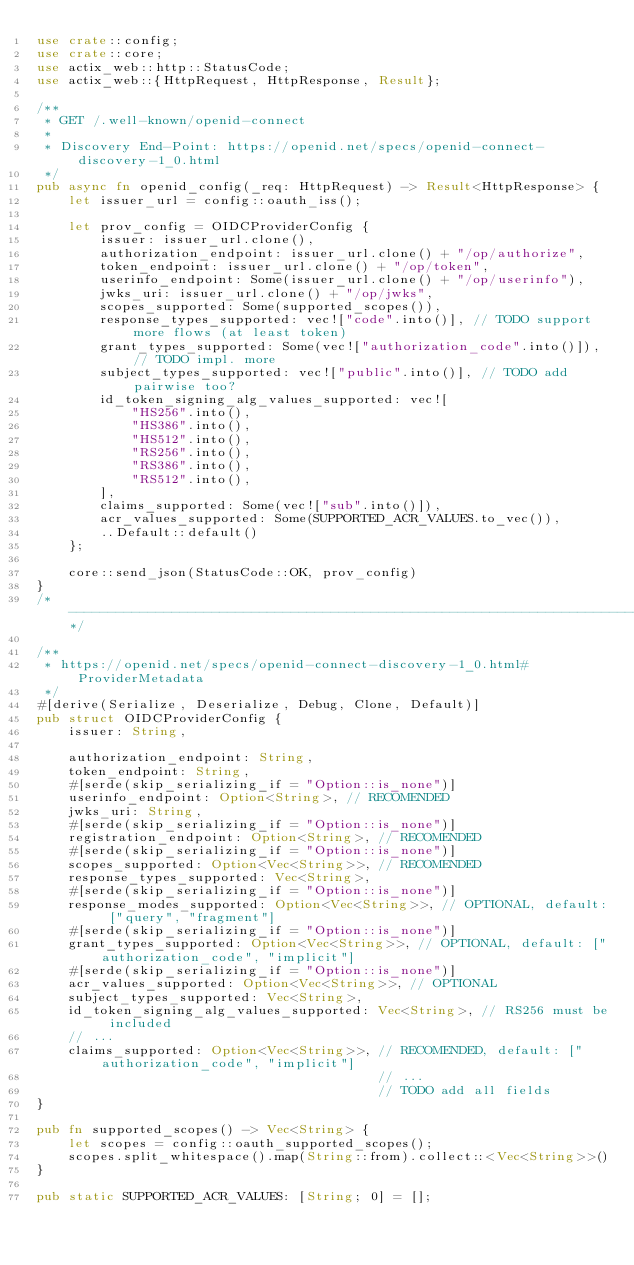Convert code to text. <code><loc_0><loc_0><loc_500><loc_500><_Rust_>use crate::config;
use crate::core;
use actix_web::http::StatusCode;
use actix_web::{HttpRequest, HttpResponse, Result};

/**
 * GET /.well-known/openid-connect
 *
 * Discovery End-Point: https://openid.net/specs/openid-connect-discovery-1_0.html
 */
pub async fn openid_config(_req: HttpRequest) -> Result<HttpResponse> {
    let issuer_url = config::oauth_iss();

    let prov_config = OIDCProviderConfig {
        issuer: issuer_url.clone(),
        authorization_endpoint: issuer_url.clone() + "/op/authorize",
        token_endpoint: issuer_url.clone() + "/op/token",
        userinfo_endpoint: Some(issuer_url.clone() + "/op/userinfo"),
        jwks_uri: issuer_url.clone() + "/op/jwks",
        scopes_supported: Some(supported_scopes()),
        response_types_supported: vec!["code".into()], // TODO support more flows (at least token)
        grant_types_supported: Some(vec!["authorization_code".into()]), // TODO impl. more
        subject_types_supported: vec!["public".into()], // TODO add pairwise too?
        id_token_signing_alg_values_supported: vec![
            "HS256".into(),
            "HS386".into(),
            "HS512".into(),
            "RS256".into(),
            "RS386".into(),
            "RS512".into(),
        ],
        claims_supported: Some(vec!["sub".into()]),
        acr_values_supported: Some(SUPPORTED_ACR_VALUES.to_vec()),
        ..Default::default()
    };

    core::send_json(StatusCode::OK, prov_config)
}
/* ---------------------------------------------------------------------------------------*/

/**
 * https://openid.net/specs/openid-connect-discovery-1_0.html#ProviderMetadata
 */
#[derive(Serialize, Deserialize, Debug, Clone, Default)]
pub struct OIDCProviderConfig {
    issuer: String,

    authorization_endpoint: String,
    token_endpoint: String,
    #[serde(skip_serializing_if = "Option::is_none")]
    userinfo_endpoint: Option<String>, // RECOMENDED
    jwks_uri: String,
    #[serde(skip_serializing_if = "Option::is_none")]
    registration_endpoint: Option<String>, // RECOMENDED
    #[serde(skip_serializing_if = "Option::is_none")]
    scopes_supported: Option<Vec<String>>, // RECOMENDED
    response_types_supported: Vec<String>,
    #[serde(skip_serializing_if = "Option::is_none")]
    response_modes_supported: Option<Vec<String>>, // OPTIONAL, default: ["query", "fragment"]
    #[serde(skip_serializing_if = "Option::is_none")]
    grant_types_supported: Option<Vec<String>>, // OPTIONAL, default: ["authorization_code", "implicit"]
    #[serde(skip_serializing_if = "Option::is_none")]
    acr_values_supported: Option<Vec<String>>, // OPTIONAL
    subject_types_supported: Vec<String>,
    id_token_signing_alg_values_supported: Vec<String>, // RS256 must be included
    // ...
    claims_supported: Option<Vec<String>>, // RECOMENDED, default: ["authorization_code", "implicit"]
                                           // ...
                                           // TODO add all fields
}

pub fn supported_scopes() -> Vec<String> {
    let scopes = config::oauth_supported_scopes();
    scopes.split_whitespace().map(String::from).collect::<Vec<String>>()
}

pub static SUPPORTED_ACR_VALUES: [String; 0] = [];
</code> 